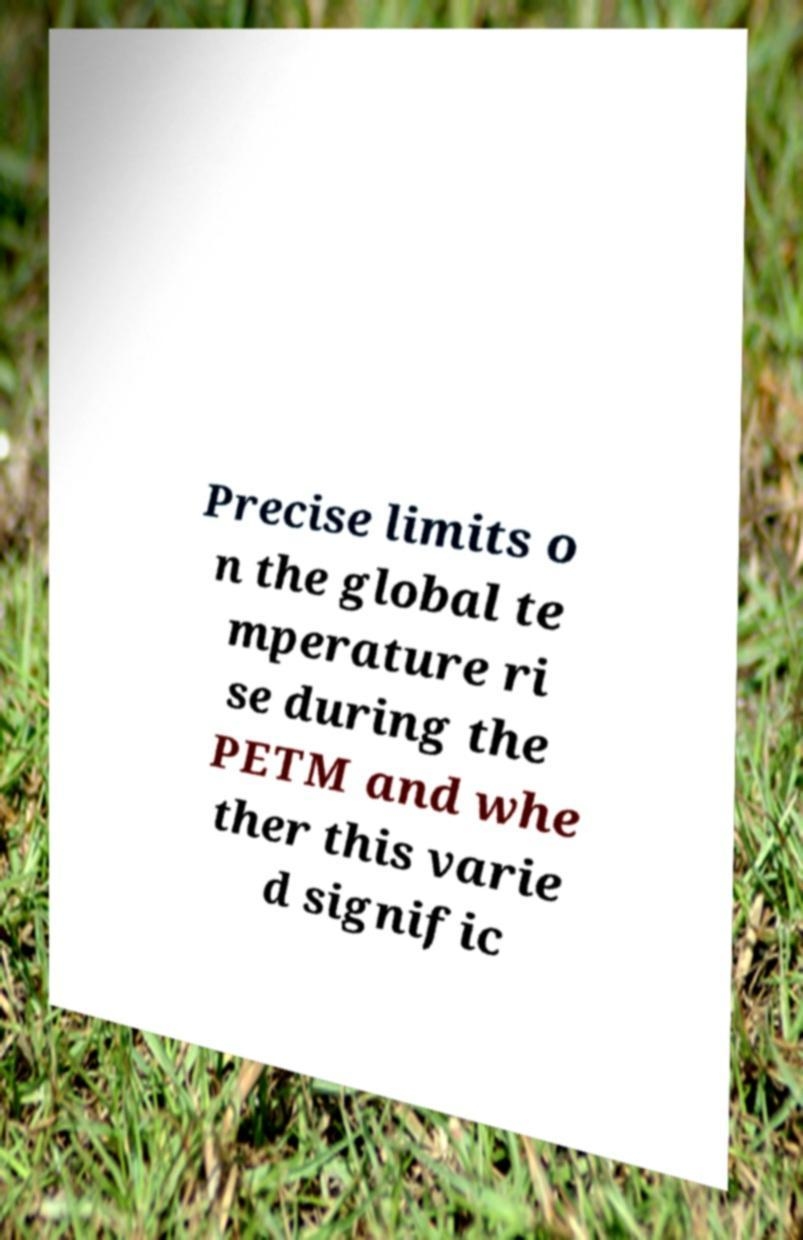What messages or text are displayed in this image? I need them in a readable, typed format. Precise limits o n the global te mperature ri se during the PETM and whe ther this varie d signific 